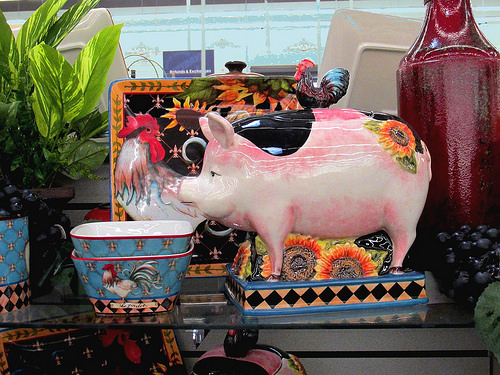<image>
Can you confirm if the pig is above the bowl? No. The pig is not positioned above the bowl. The vertical arrangement shows a different relationship. Is there a chicken on the pig? Yes. Looking at the image, I can see the chicken is positioned on top of the pig, with the pig providing support. 